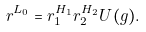Convert formula to latex. <formula><loc_0><loc_0><loc_500><loc_500>r ^ { L _ { 0 } } = r _ { 1 } ^ { H _ { 1 } } r _ { 2 } ^ { H _ { 2 } } U ( g ) .</formula> 